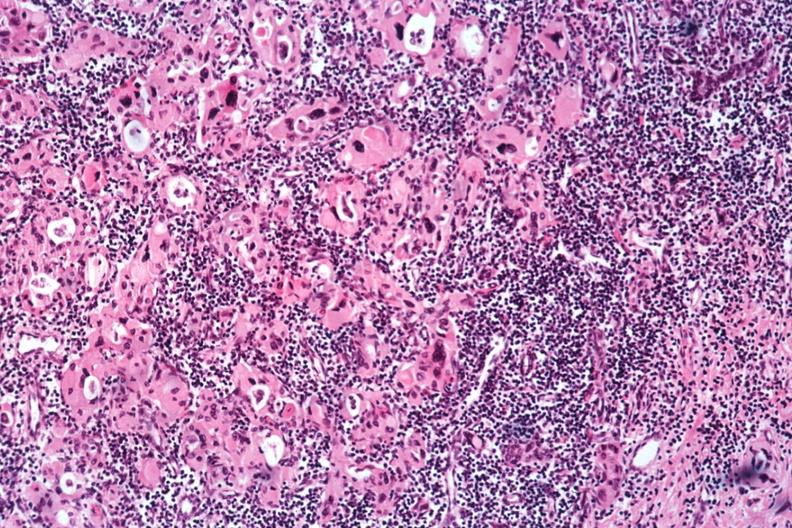what is present?
Answer the question using a single word or phrase. Autoimmune thyroiditis 